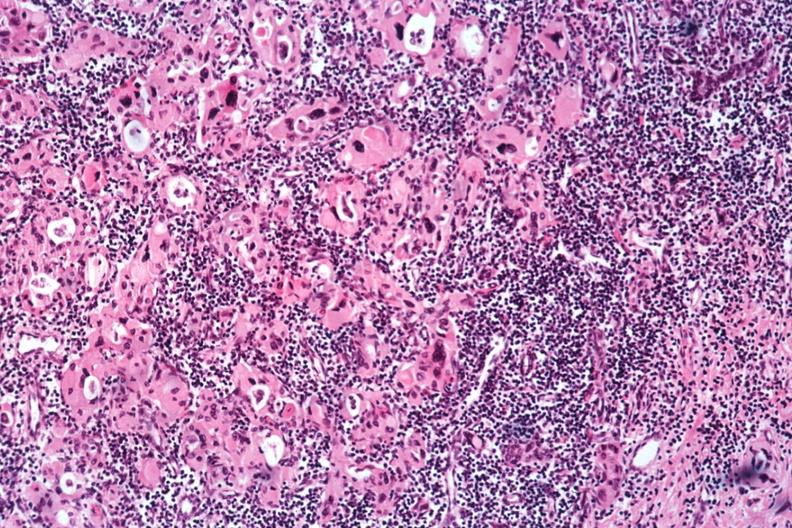what is present?
Answer the question using a single word or phrase. Autoimmune thyroiditis 